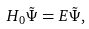Convert formula to latex. <formula><loc_0><loc_0><loc_500><loc_500>H _ { 0 } \tilde { \Psi } = E \tilde { \Psi } ,</formula> 